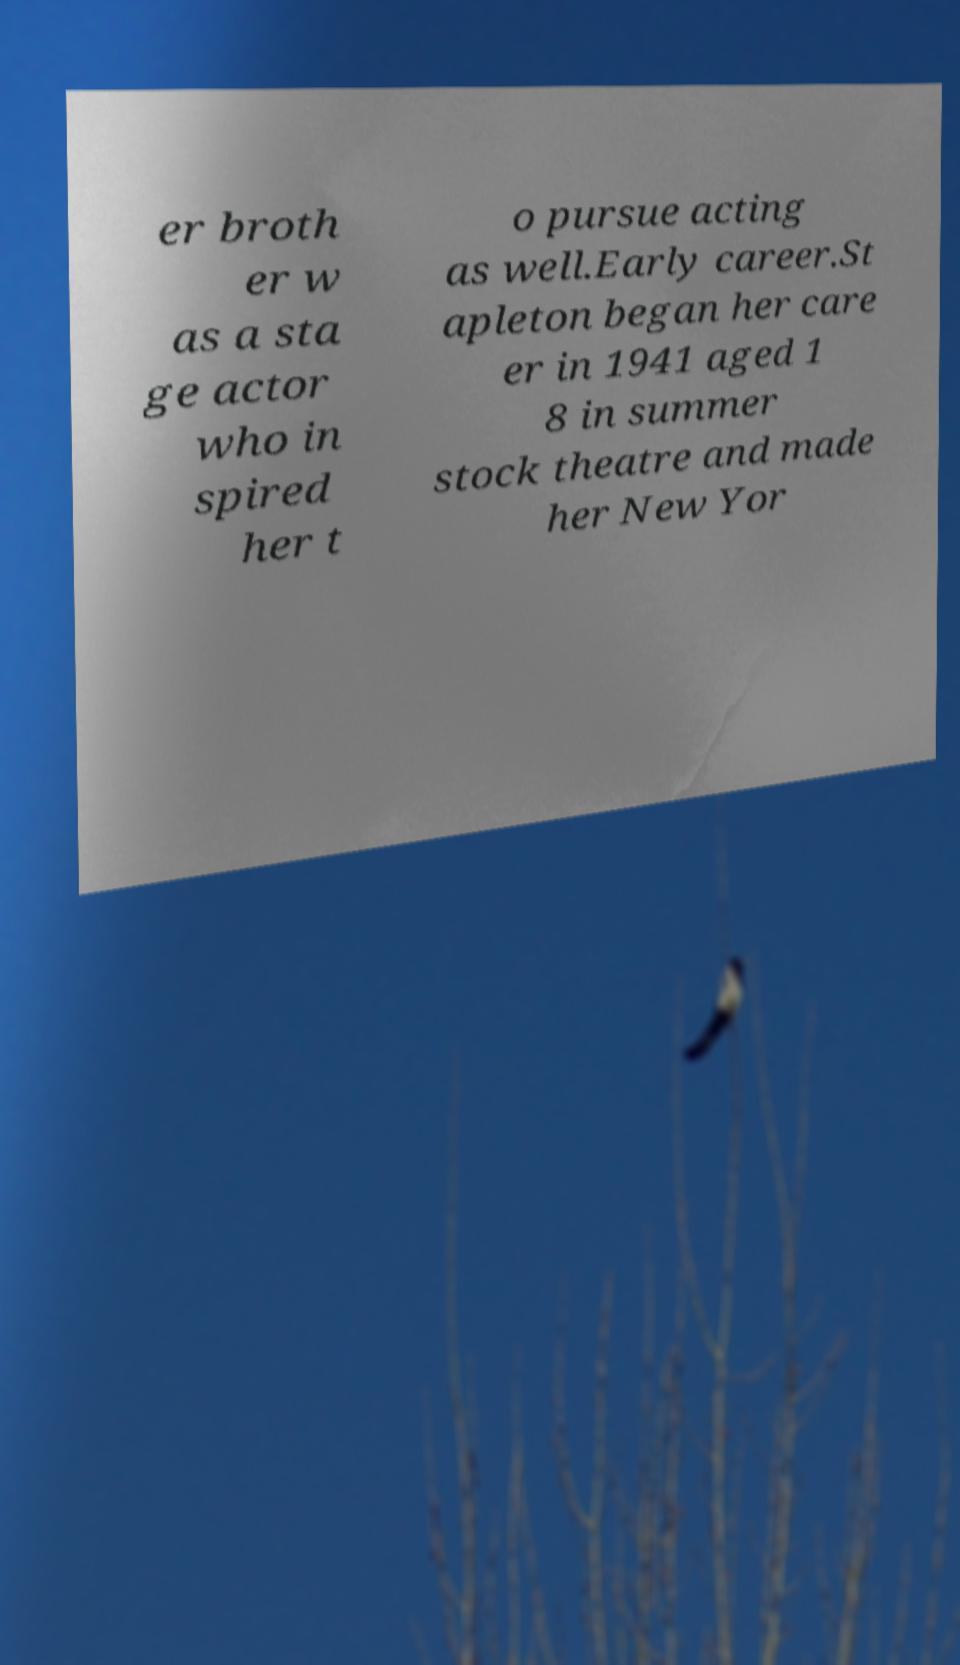Could you extract and type out the text from this image? er broth er w as a sta ge actor who in spired her t o pursue acting as well.Early career.St apleton began her care er in 1941 aged 1 8 in summer stock theatre and made her New Yor 